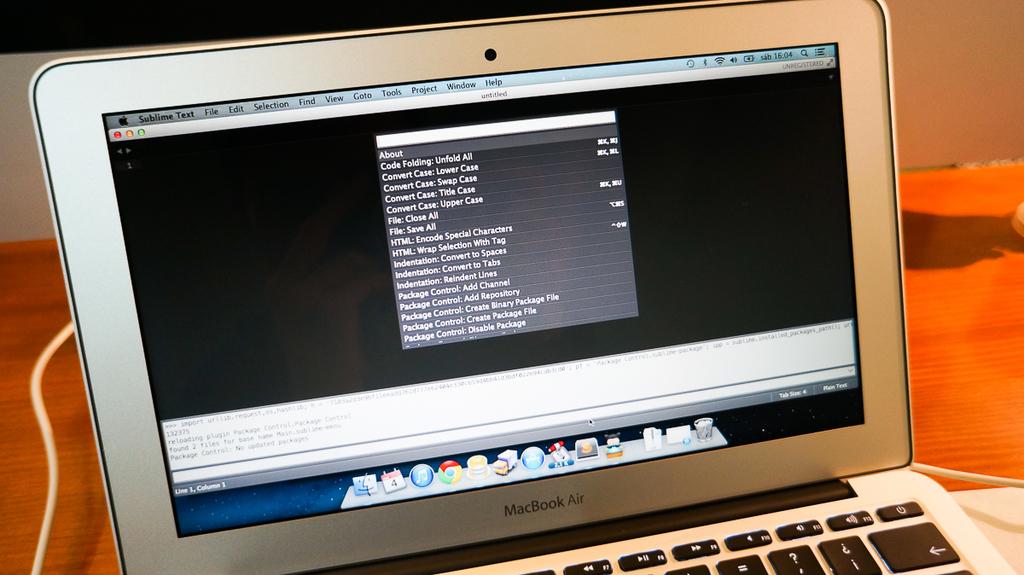What type of macbook is shown?
Give a very brief answer. Air. 